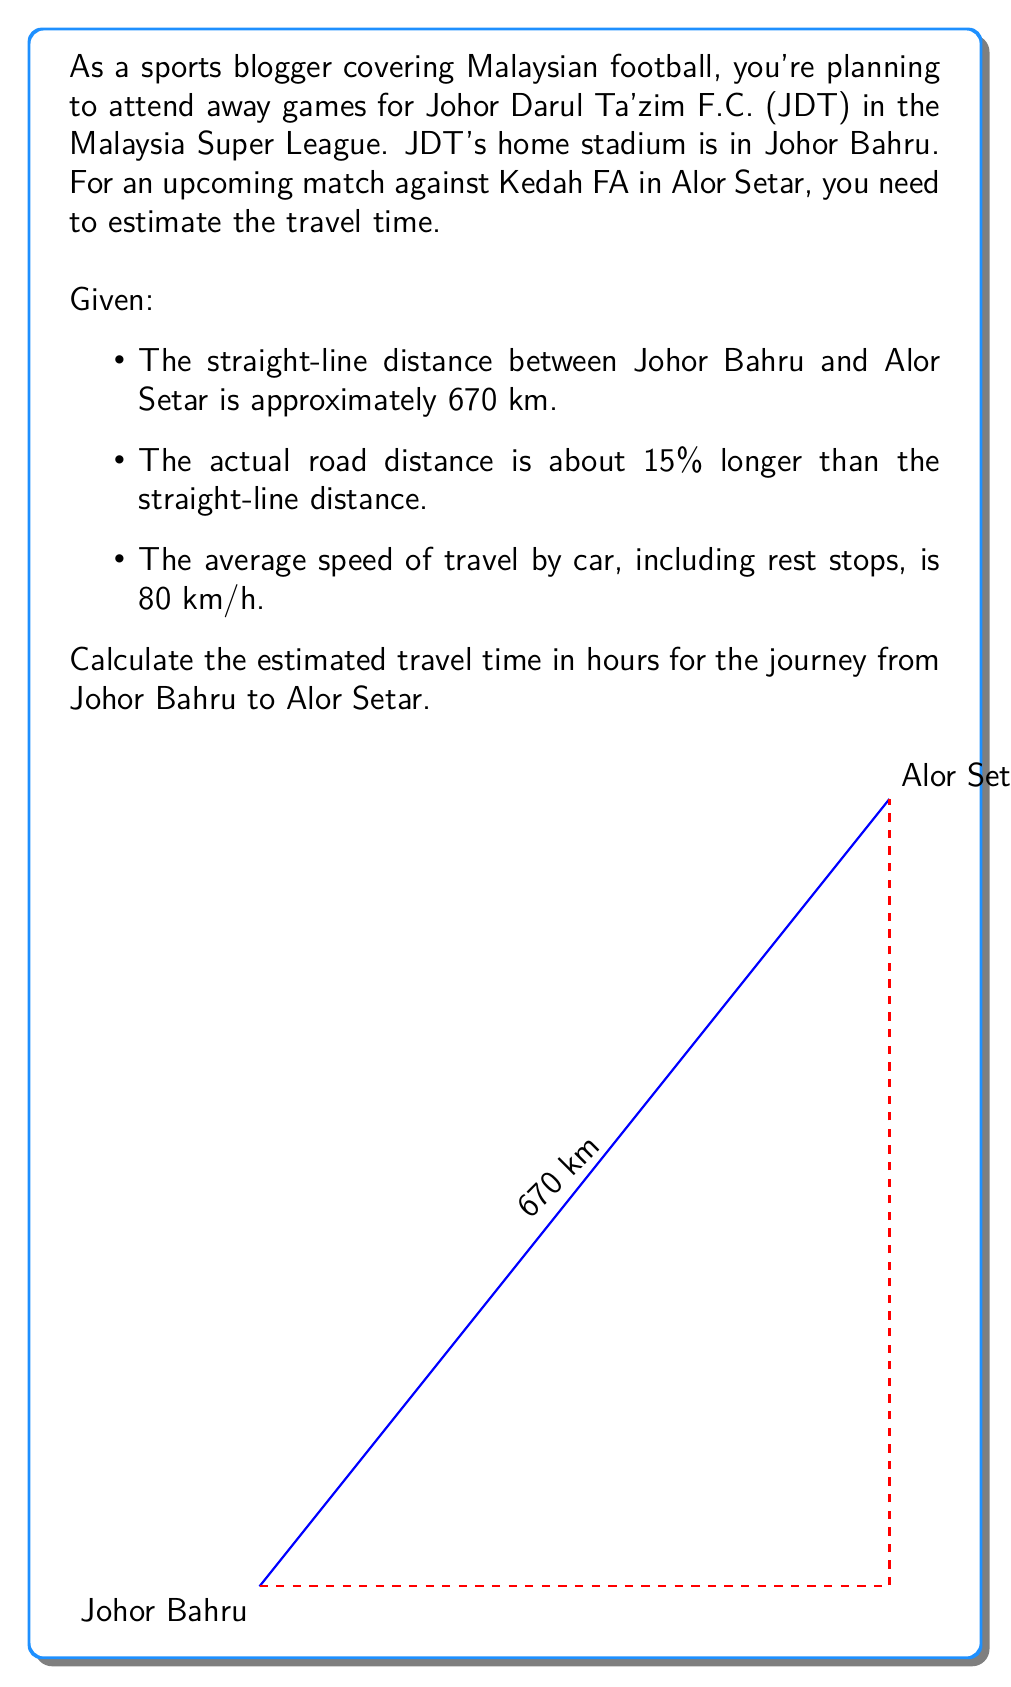Show me your answer to this math problem. Let's break this down step-by-step:

1) First, we need to calculate the actual road distance:
   - Straight-line distance = 670 km
   - Road distance is 15% longer
   - Let's calculate this: $670 \times 1.15 = 770.5$ km

2) Now we have the distance and the average speed:
   - Distance = 770.5 km
   - Average speed = 80 km/h

3) To calculate time, we use the formula:
   $$ \text{Time} = \frac{\text{Distance}}{\text{Speed}} $$

4) Plugging in our values:
   $$ \text{Time} = \frac{770.5 \text{ km}}{80 \text{ km/h}} = 9.63125 \text{ hours} $$

5) Rounding to the nearest quarter hour for practicality:
   9.63125 hours ≈ 9 hours and 38 minutes ≈ 9.75 hours

Therefore, the estimated travel time from Johor Bahru to Alor Setar is approximately 9.75 hours.
Answer: 9.75 hours 